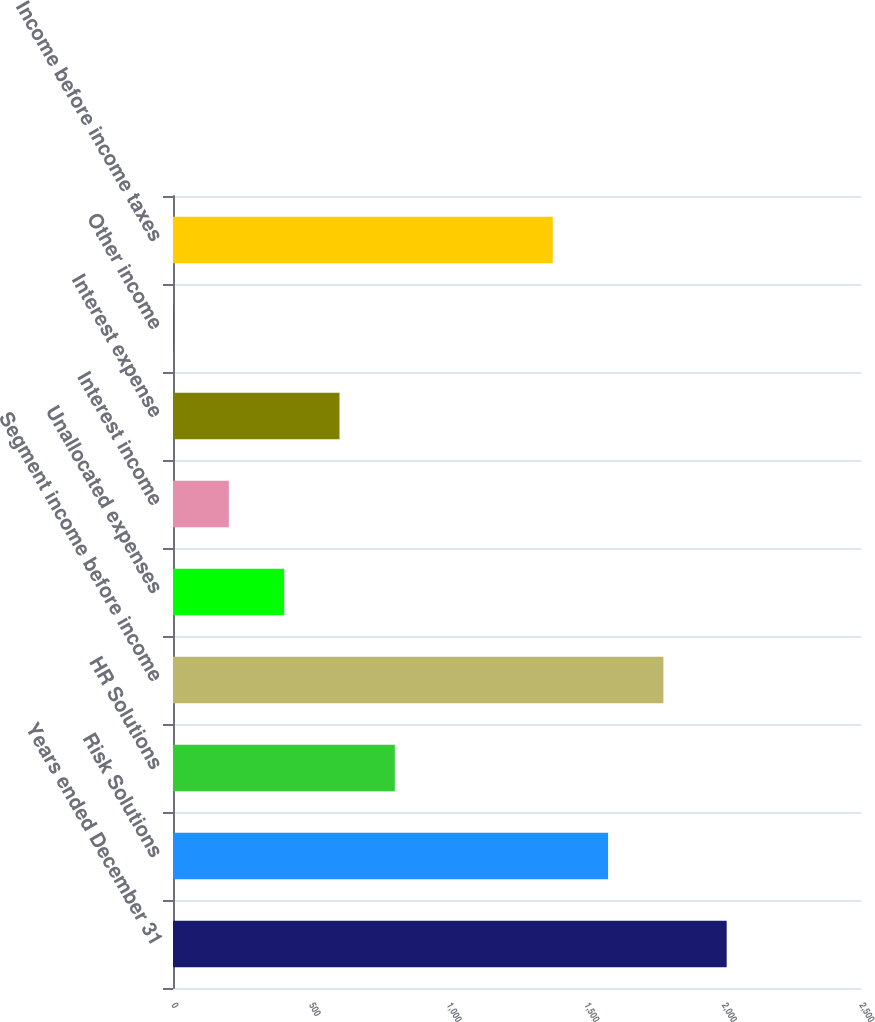Convert chart to OTSL. <chart><loc_0><loc_0><loc_500><loc_500><bar_chart><fcel>Years ended December 31<fcel>Risk Solutions<fcel>HR Solutions<fcel>Segment income before income<fcel>Unallocated expenses<fcel>Interest income<fcel>Interest expense<fcel>Other income<fcel>Income before income taxes<nl><fcel>2012<fcel>1581<fcel>806<fcel>1782<fcel>404<fcel>203<fcel>605<fcel>2<fcel>1380<nl></chart> 